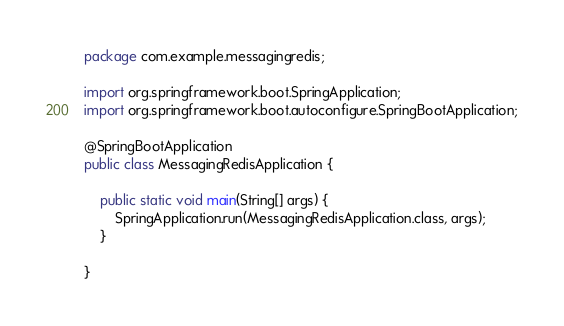<code> <loc_0><loc_0><loc_500><loc_500><_Java_>package com.example.messagingredis;

import org.springframework.boot.SpringApplication;
import org.springframework.boot.autoconfigure.SpringBootApplication;

@SpringBootApplication
public class MessagingRedisApplication {

	public static void main(String[] args) {
		SpringApplication.run(MessagingRedisApplication.class, args);
	}
	
}
</code> 